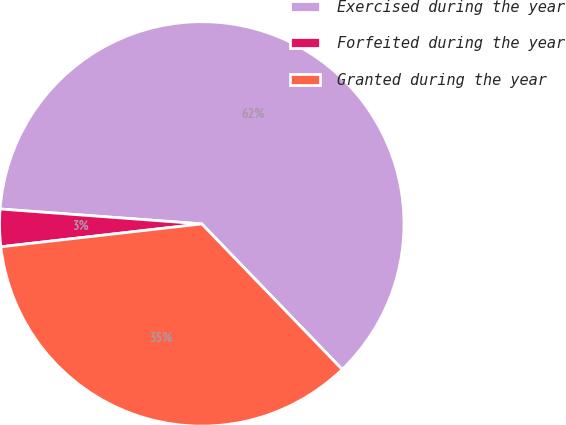Convert chart. <chart><loc_0><loc_0><loc_500><loc_500><pie_chart><fcel>Exercised during the year<fcel>Forfeited during the year<fcel>Granted during the year<nl><fcel>61.61%<fcel>2.98%<fcel>35.41%<nl></chart> 